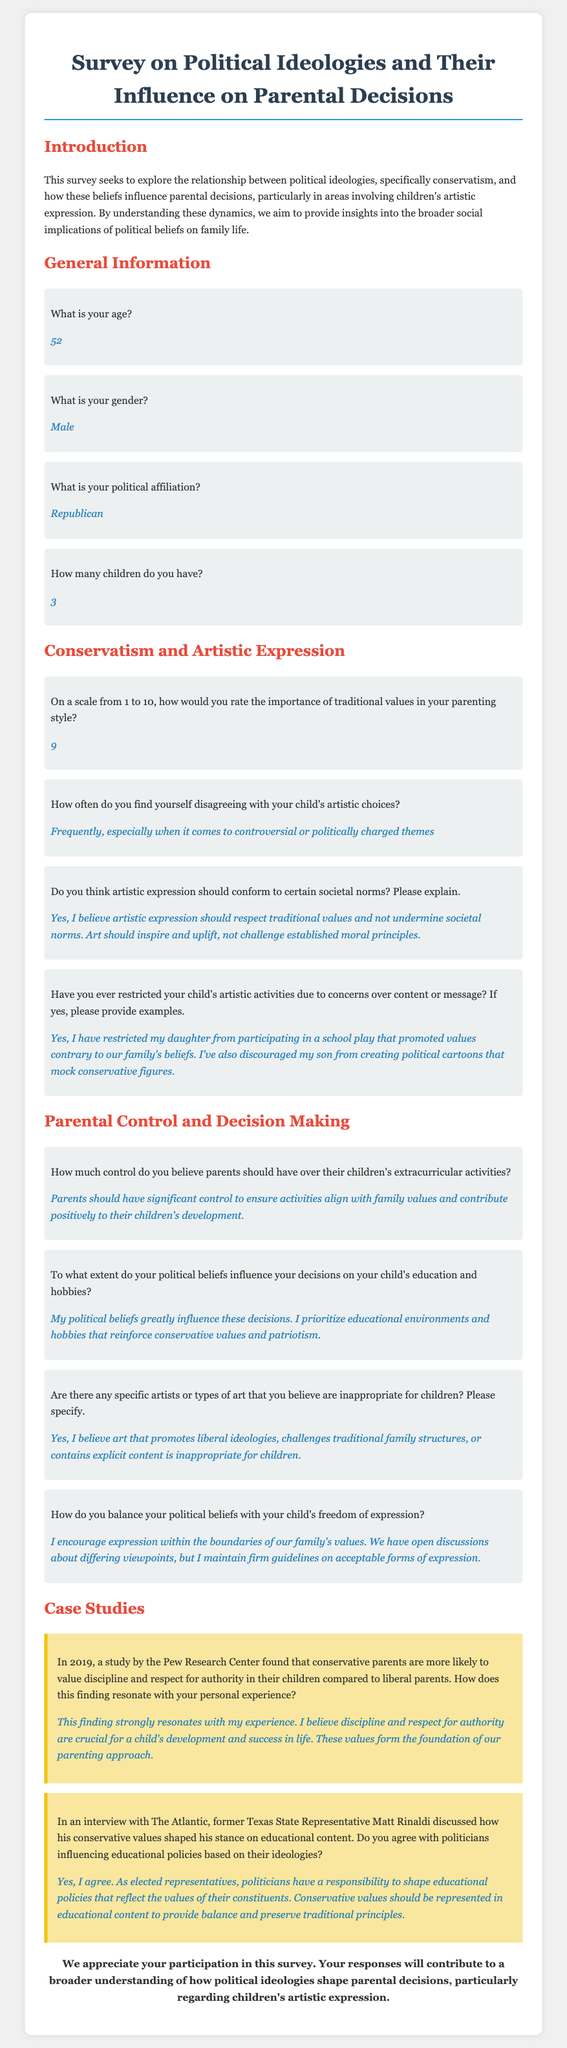What is your age? The document states the respondent's age as part of the general information section.
Answer: 52 What is your political affiliation? The political affiliation of the respondent is clearly mentioned in the document under general information.
Answer: Republican How often do you find yourself disagreeing with your child's artistic choices? This question is answered in the section about conservatism and artistic expression, indicating the frequency of disagreement.
Answer: Frequently, especially when it comes to controversial or politically charged themes How much control do you believe parents should have over their children's extracurricular activities? The respondent's beliefs about parental control in extracurricular activities are discussed in the parental control section of the document.
Answer: Significant control Do you think artistic expression should conform to certain societal norms? This question seeks to summarize the respondent's beliefs regarding artistic expression against societal norms, which is provided in the document.
Answer: Yes, I believe artistic expression should respect traditional values and not undermine societal norms 